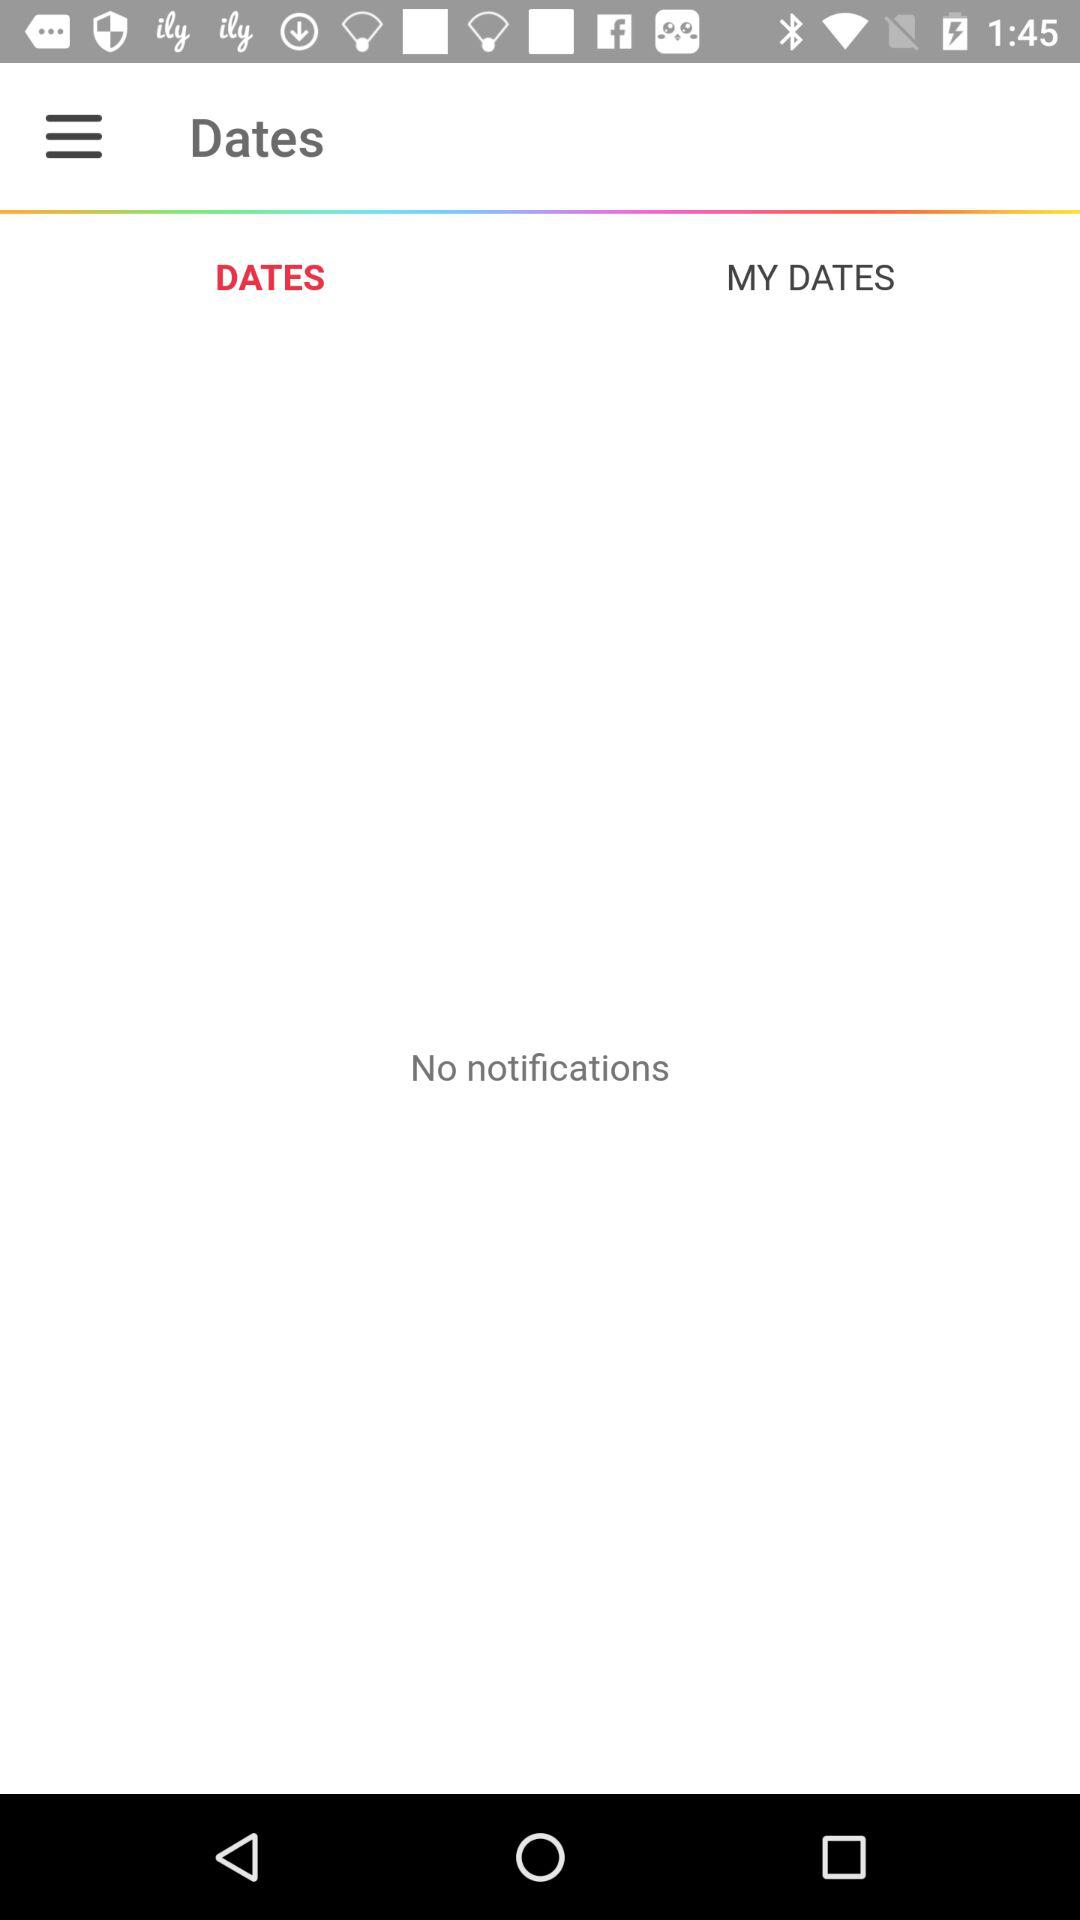Is there any notification? There is no notification. 